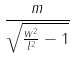Convert formula to latex. <formula><loc_0><loc_0><loc_500><loc_500>\frac { m } { \sqrt { \frac { w ^ { 2 } } { l ^ { 2 } } - 1 } }</formula> 